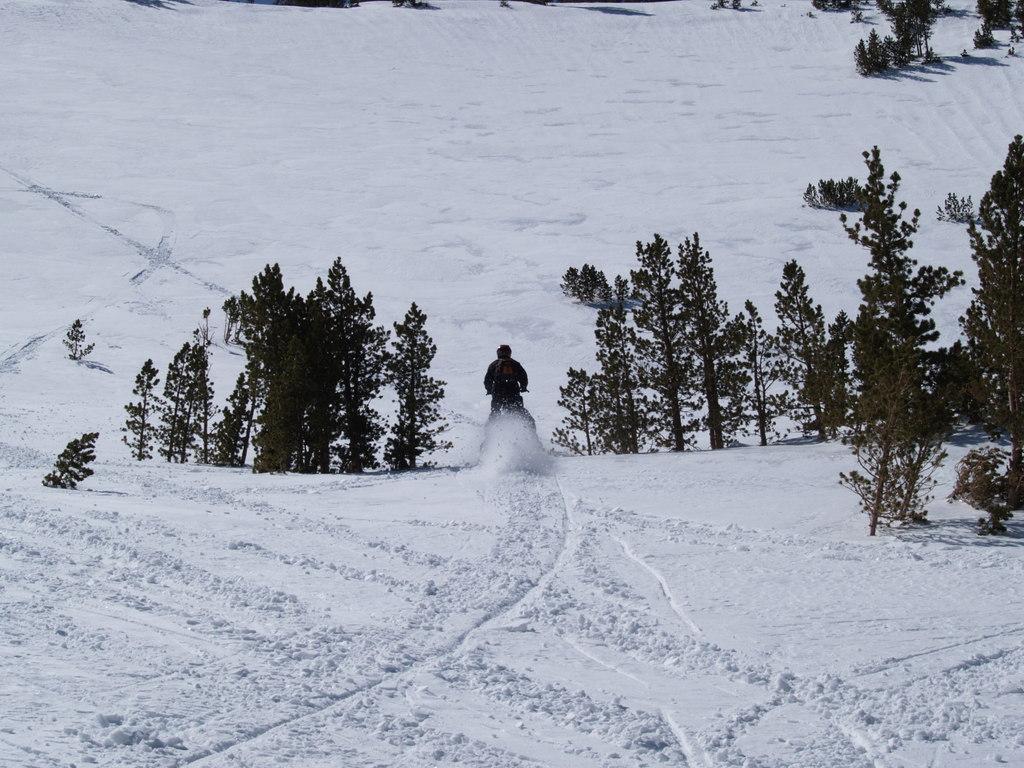Describe this image in one or two sentences. In this image I can see the snow and there are trees. In the middle of the image there is a person riding a vehicle towards the back side. 